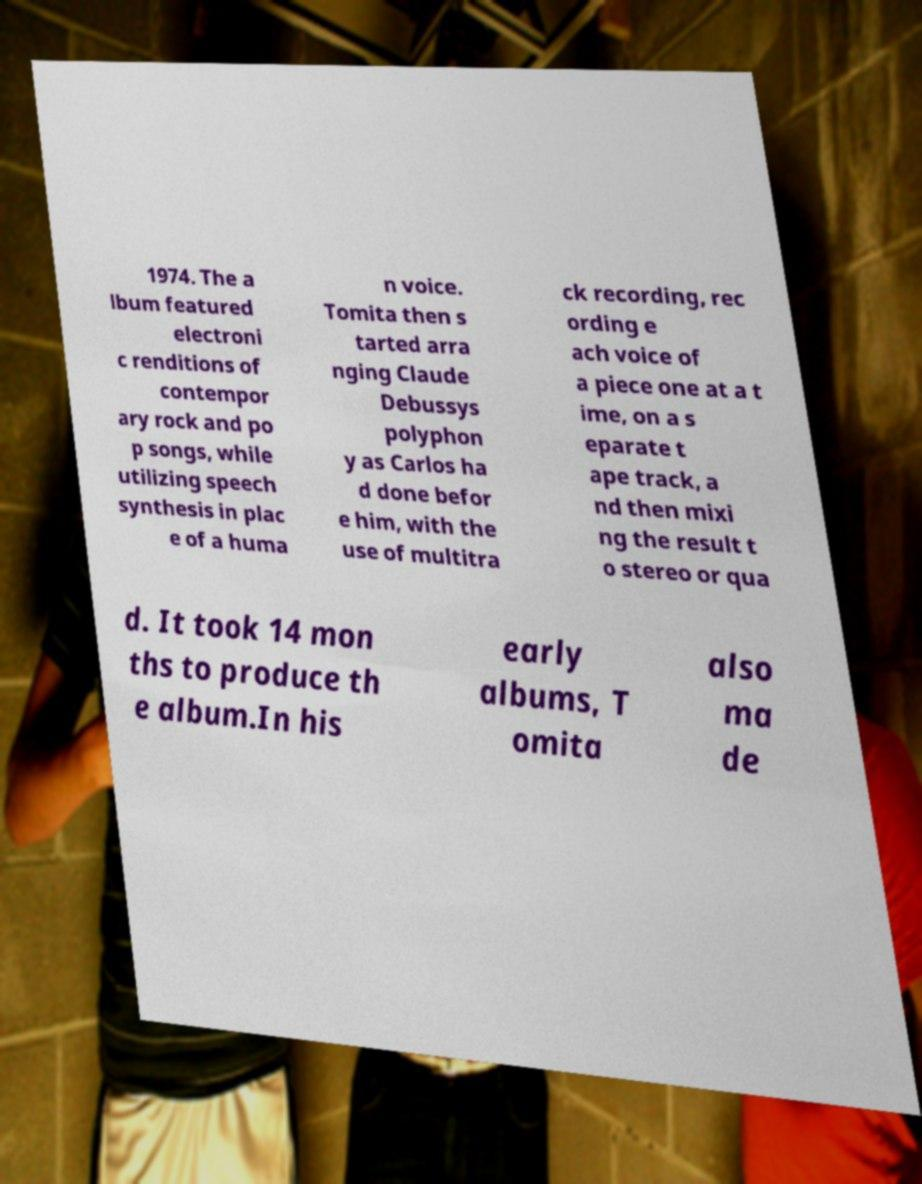Please identify and transcribe the text found in this image. 1974. The a lbum featured electroni c renditions of contempor ary rock and po p songs, while utilizing speech synthesis in plac e of a huma n voice. Tomita then s tarted arra nging Claude Debussys polyphon y as Carlos ha d done befor e him, with the use of multitra ck recording, rec ording e ach voice of a piece one at a t ime, on a s eparate t ape track, a nd then mixi ng the result t o stereo or qua d. It took 14 mon ths to produce th e album.In his early albums, T omita also ma de 